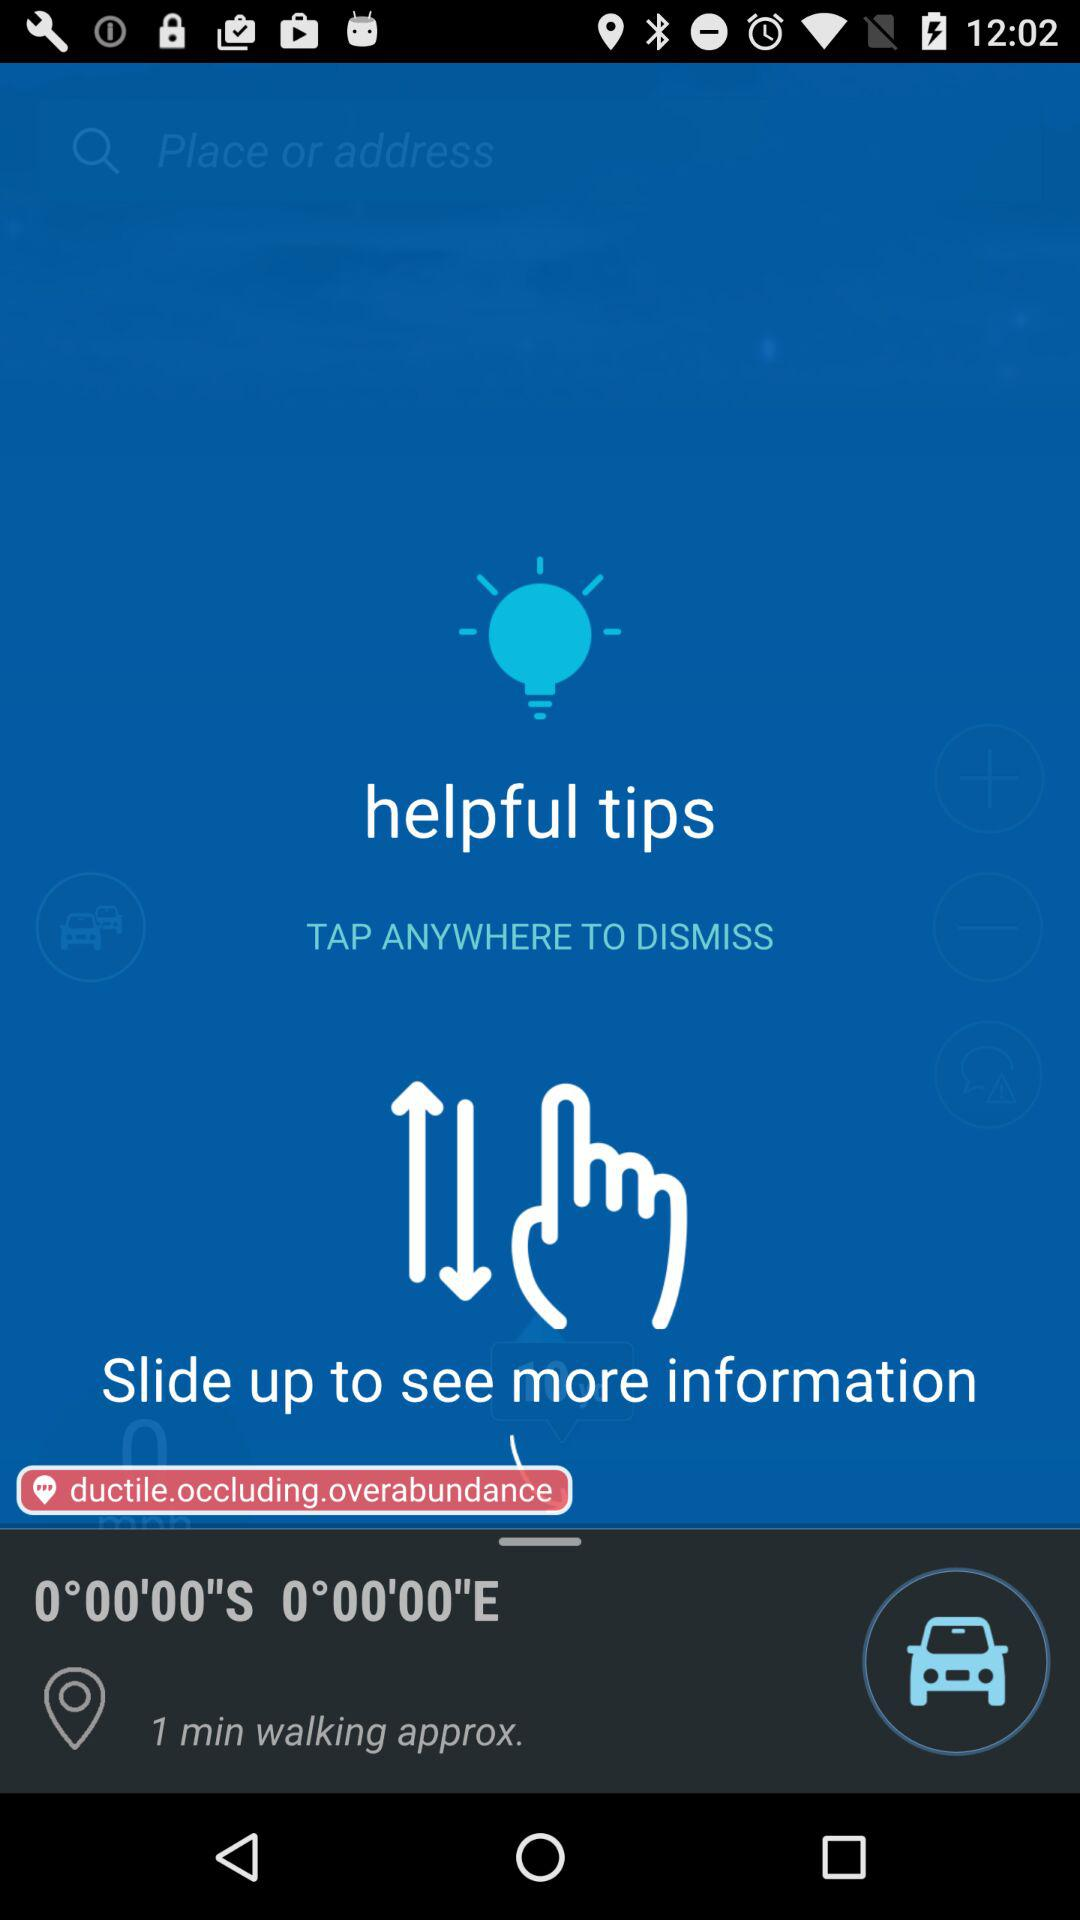How many minutes does it take to walk to this location?
Answer the question using a single word or phrase. 1 min 